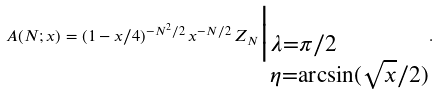<formula> <loc_0><loc_0><loc_500><loc_500>A ( N ; x ) = ( 1 - x / 4 ) ^ { - N ^ { 2 } / 2 } \, x ^ { - N / 2 } \, Z _ { N } \Big | _ { \begin{subarray} { l } \lambda = \pi / 2 \\ \eta = \arcsin ( \sqrt { x } / 2 ) \end{subarray} } .</formula> 